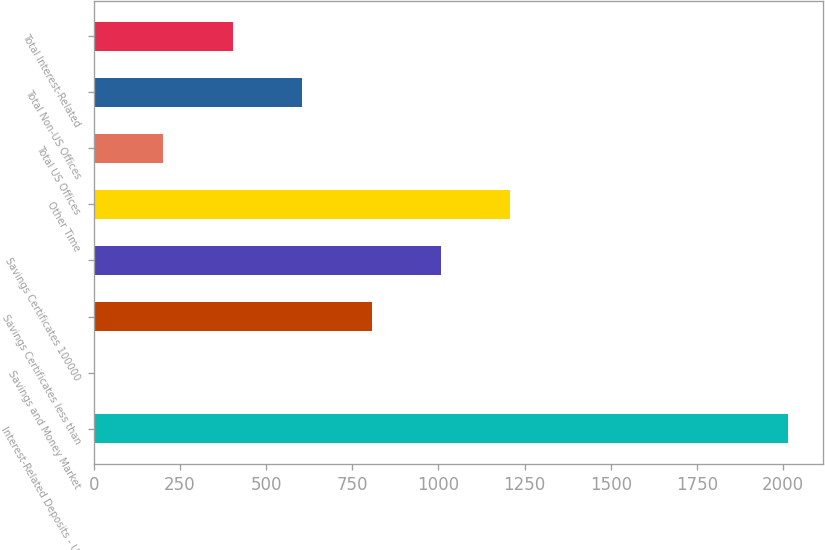<chart> <loc_0><loc_0><loc_500><loc_500><bar_chart><fcel>Interest-Related Deposits - US<fcel>Savings and Money Market<fcel>Savings Certificates less than<fcel>Savings Certificates 100000<fcel>Other Time<fcel>Total US Offices<fcel>Total Non-US Offices<fcel>Total Interest-Related<nl><fcel>2015<fcel>0.06<fcel>806.02<fcel>1007.51<fcel>1209<fcel>201.55<fcel>604.53<fcel>403.04<nl></chart> 